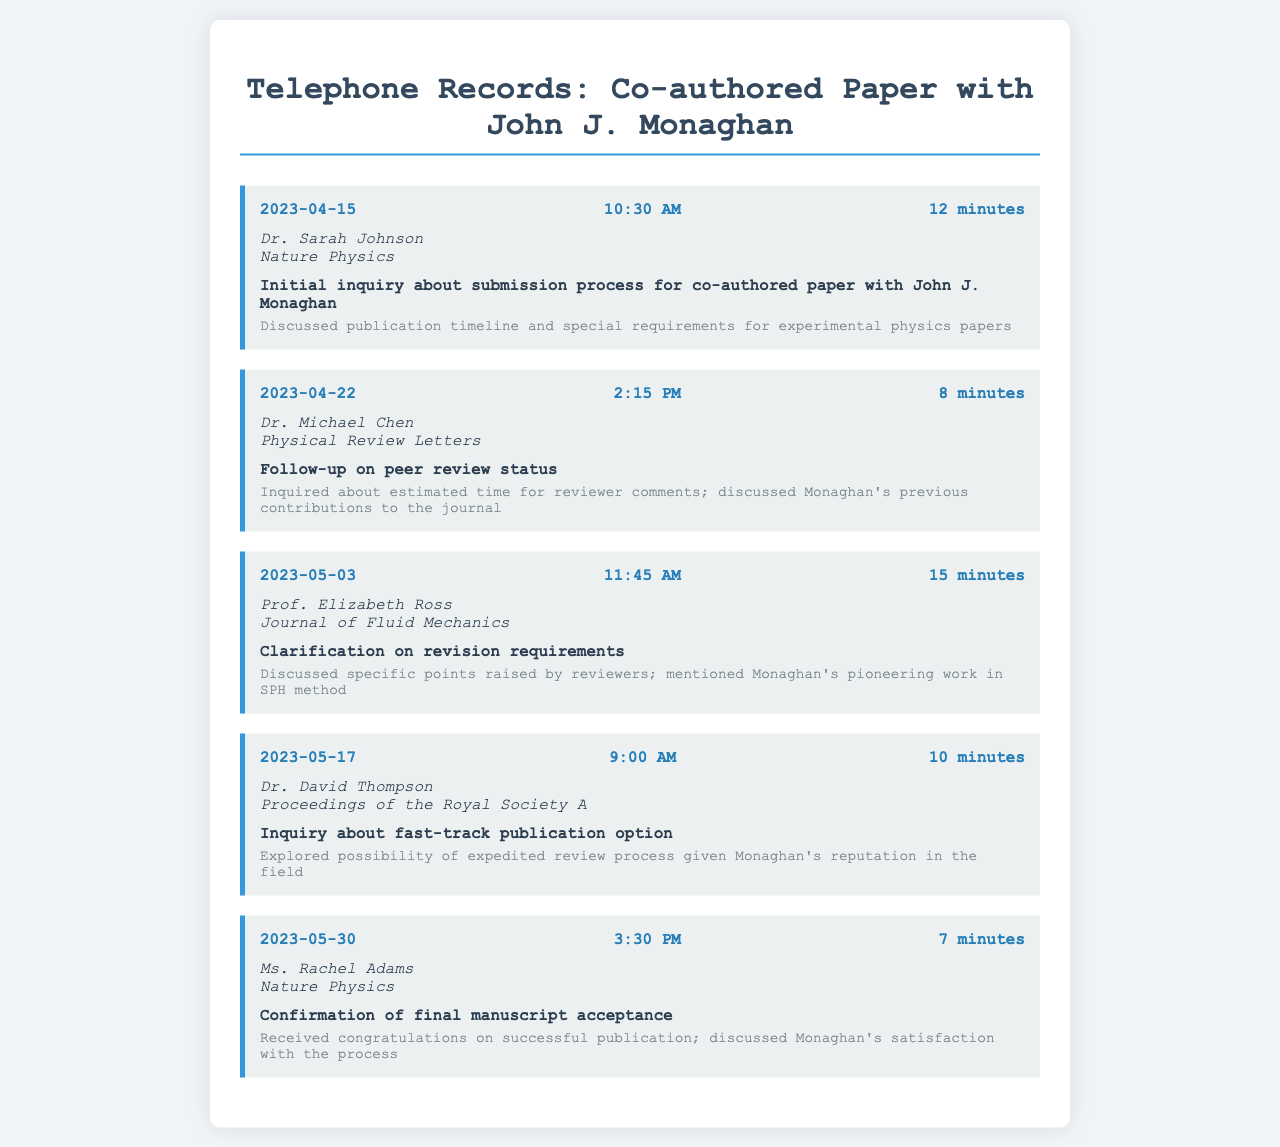What was the date of the first call? The first call was made on April 15, 2023.
Answer: April 15, 2023 Who was the recipient of the call on May 3, 2023? The call on May 3, 2023, was made to Prof. Elizabeth Ross.
Answer: Prof. Elizabeth Ross What was the duration of the call with Dr. David Thompson? The call with Dr. David Thompson lasted 10 minutes.
Answer: 10 minutes Which journal was associated with the call made on April 22, 2023? The call made on April 22, 2023, was associated with Physical Review Letters.
Answer: Physical Review Letters What was the purpose of the call with Dr. Sarah Johnson? The purpose of the call with Dr. Sarah Johnson was an initial inquiry about submission process.
Answer: Initial inquiry about submission process How many minutes did the call on May 30, 2023, last? The call on May 30, 2023, lasted 7 minutes.
Answer: 7 minutes What special topic did Dr. Michael Chen discuss during the call? Dr. Michael Chen discussed the estimated time for reviewer comments.
Answer: Estimated time for reviewer comments What was discussed in the call with Ms. Rachel Adams? The call with Ms. Rachel Adams discussed the confirmation of final manuscript acceptance.
Answer: Confirmation of final manuscript acceptance Which call included a discussion about Monaghan's previous contributions? The call with Dr. Michael Chen included a discussion about Monaghan's previous contributions.
Answer: The call with Dr. Michael Chen 